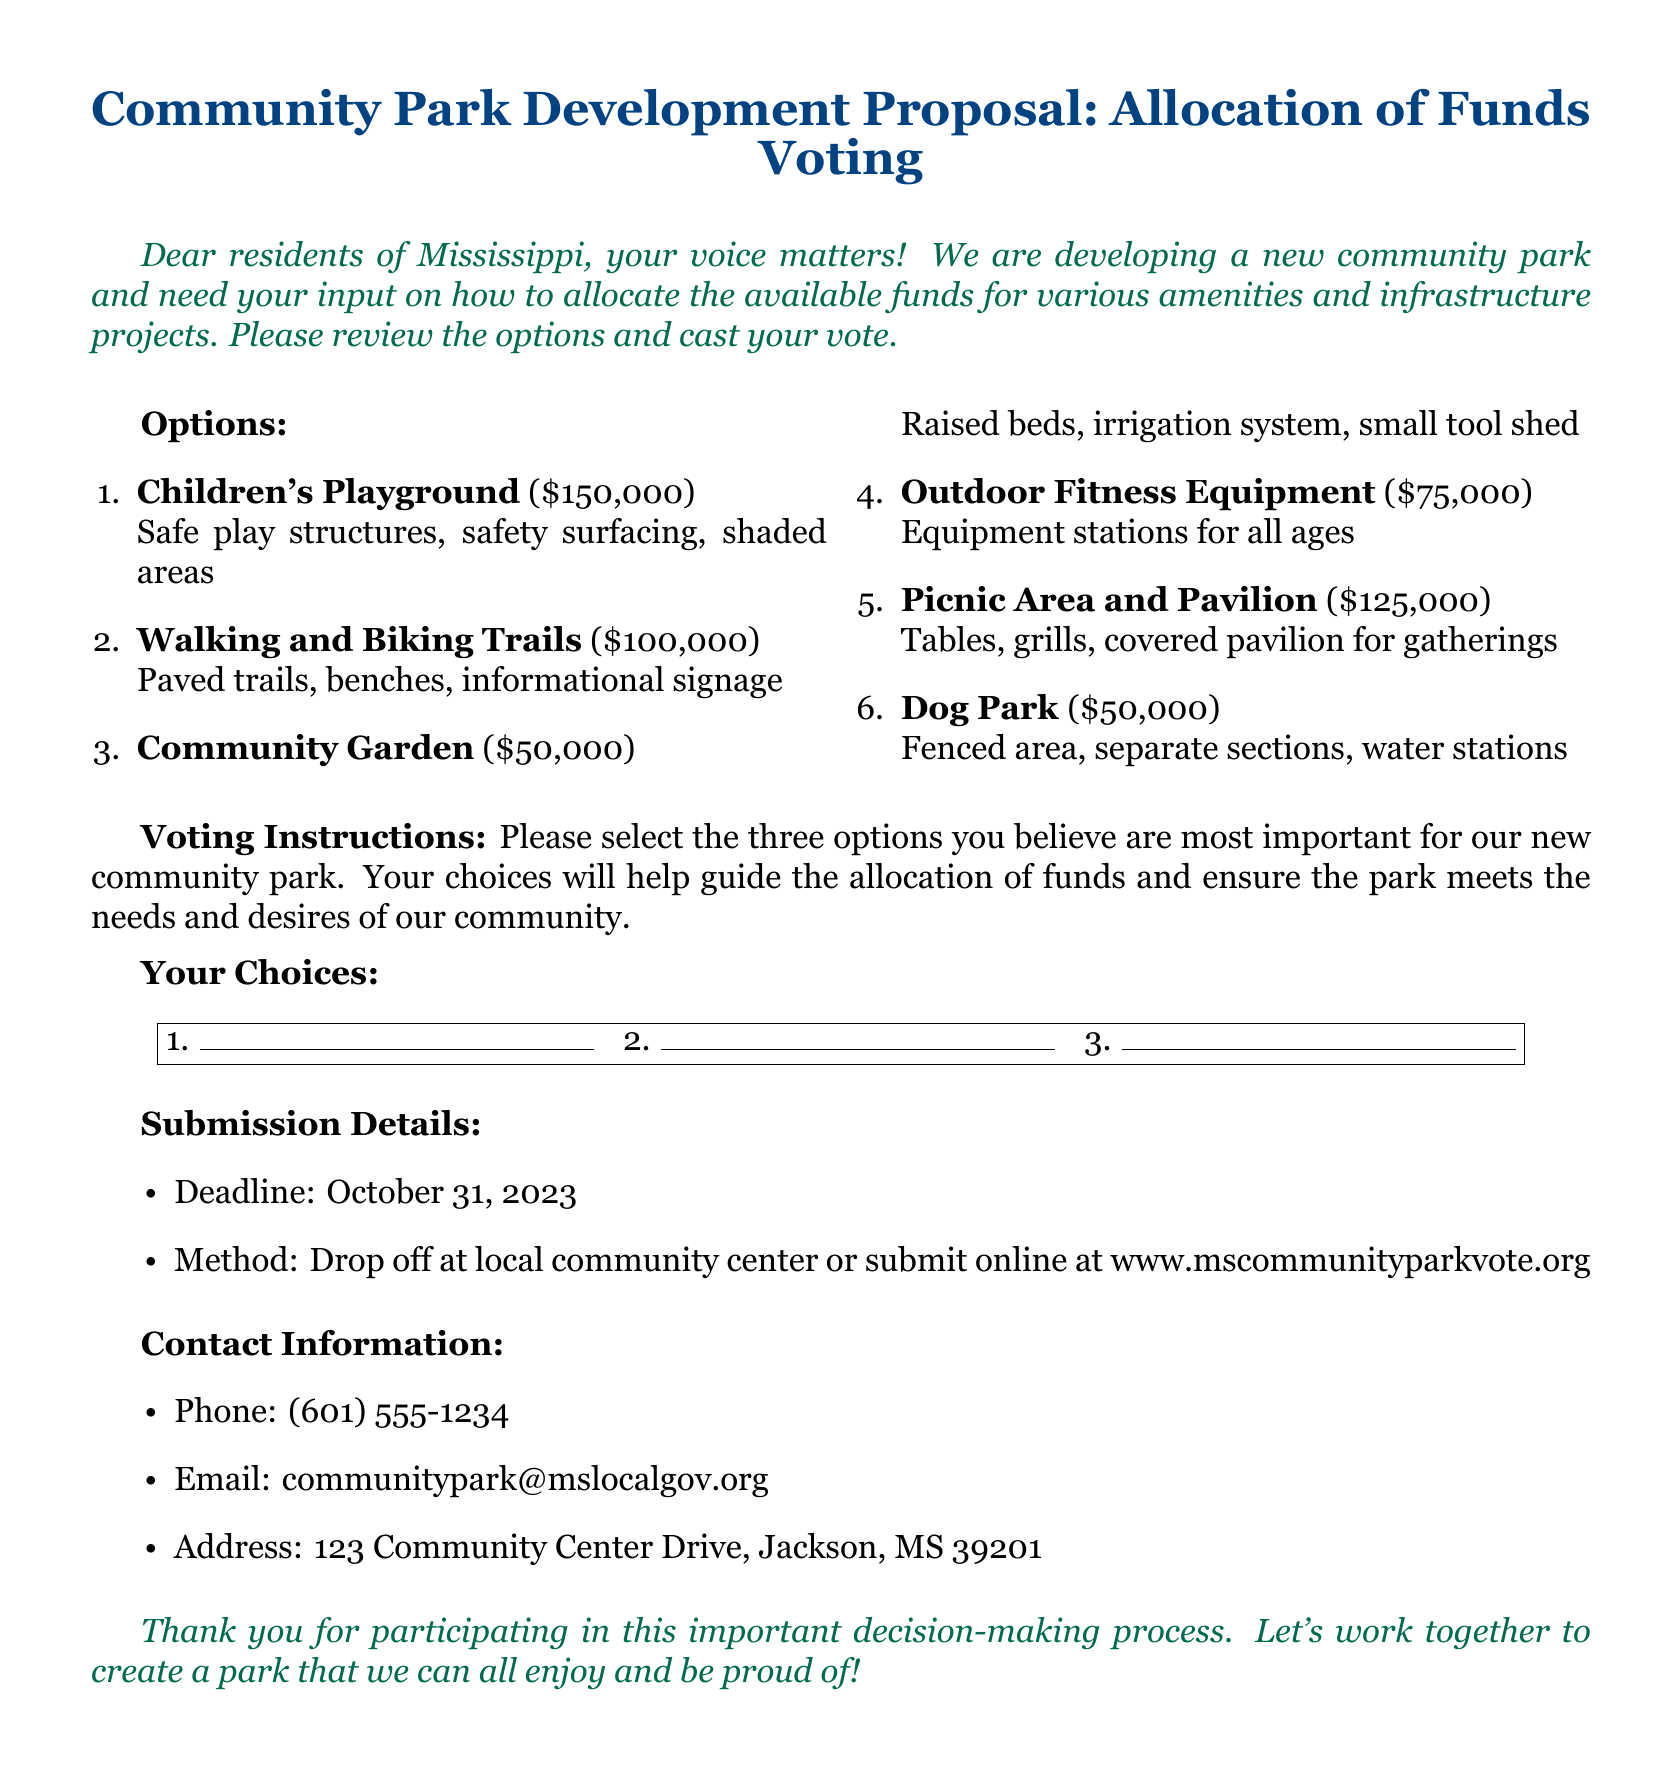What is the total funding available for the park development? The funding is composed of various project costs listed in the document, totaling $650,000 from the sum of all options provided.
Answer: $650,000 What is the deadline for submitting votes? The deadline for submissions is specifically mentioned near the end of the document as October 31, 2023.
Answer: October 31, 2023 How many options can voters select for the park development? The voting instructions indicate that participants should select three options for allocation of funds.
Answer: Three options What is the cost of the Children's Playground? The document lists the Children's Playground with a specific allocation of funds amounting to a total of $150,000.
Answer: $150,000 What type of amenities does the Dog Park offer? The Dog Park is described in the document as having a fenced area, separate sections, and water stations as amenities.
Answer: Fenced area, separate sections, water stations What is the address for submitting ballots? The address where ballots can be submitted is provided in the contact section of the document as 123 Community Center Drive, Jackson, MS 39201.
Answer: 123 Community Center Drive, Jackson, MS 39201 What is the email address for questions regarding the park development? The document provides a specific email address for inquiries as communitypark@mslocalgov.org.
Answer: communitypark@mslocalgov.org What infrastructure is included in the Walking and Biking Trails option? The document lists paved trails, benches, and informational signage as the key infrastructure for the Walking and Biking Trails.
Answer: Paved trails, benches, informational signage 